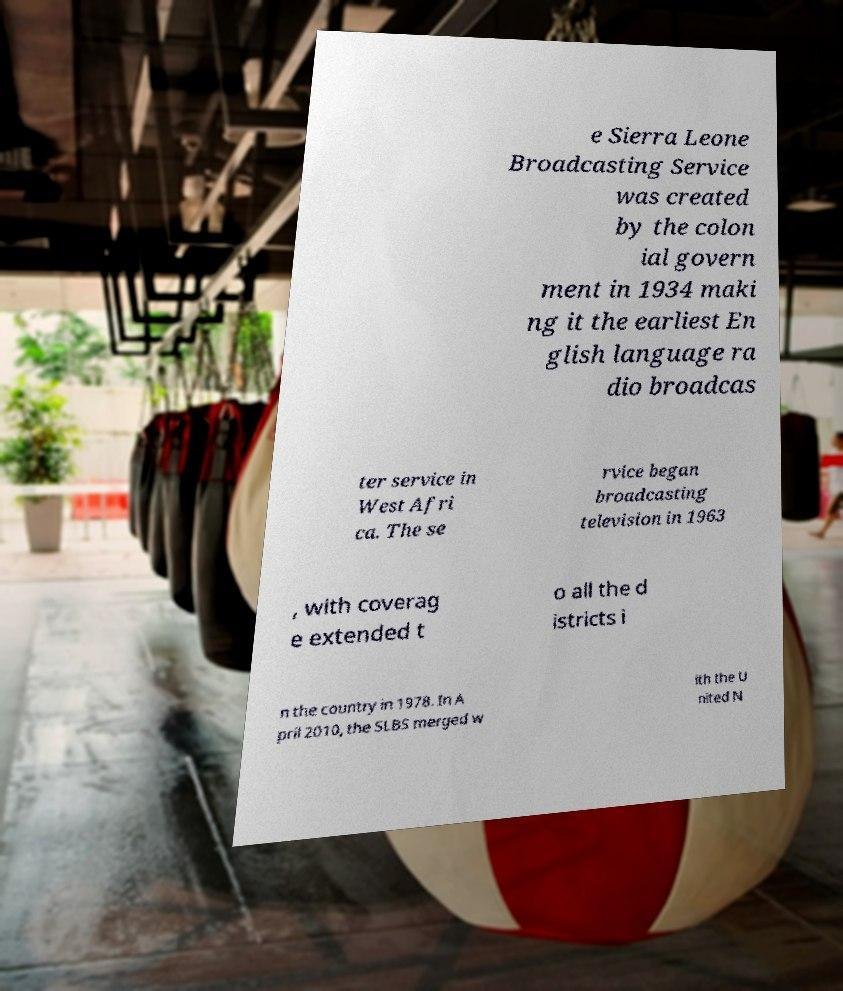Can you accurately transcribe the text from the provided image for me? e Sierra Leone Broadcasting Service was created by the colon ial govern ment in 1934 maki ng it the earliest En glish language ra dio broadcas ter service in West Afri ca. The se rvice began broadcasting television in 1963 , with coverag e extended t o all the d istricts i n the country in 1978. In A pril 2010, the SLBS merged w ith the U nited N 